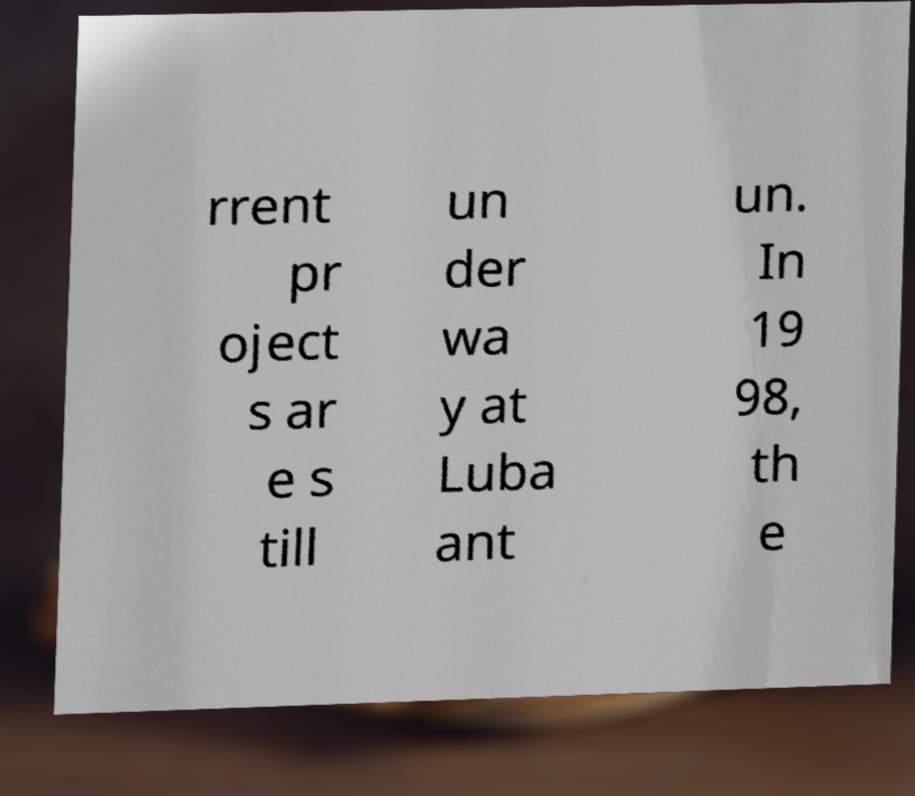Could you assist in decoding the text presented in this image and type it out clearly? rrent pr oject s ar e s till un der wa y at Luba ant un. In 19 98, th e 